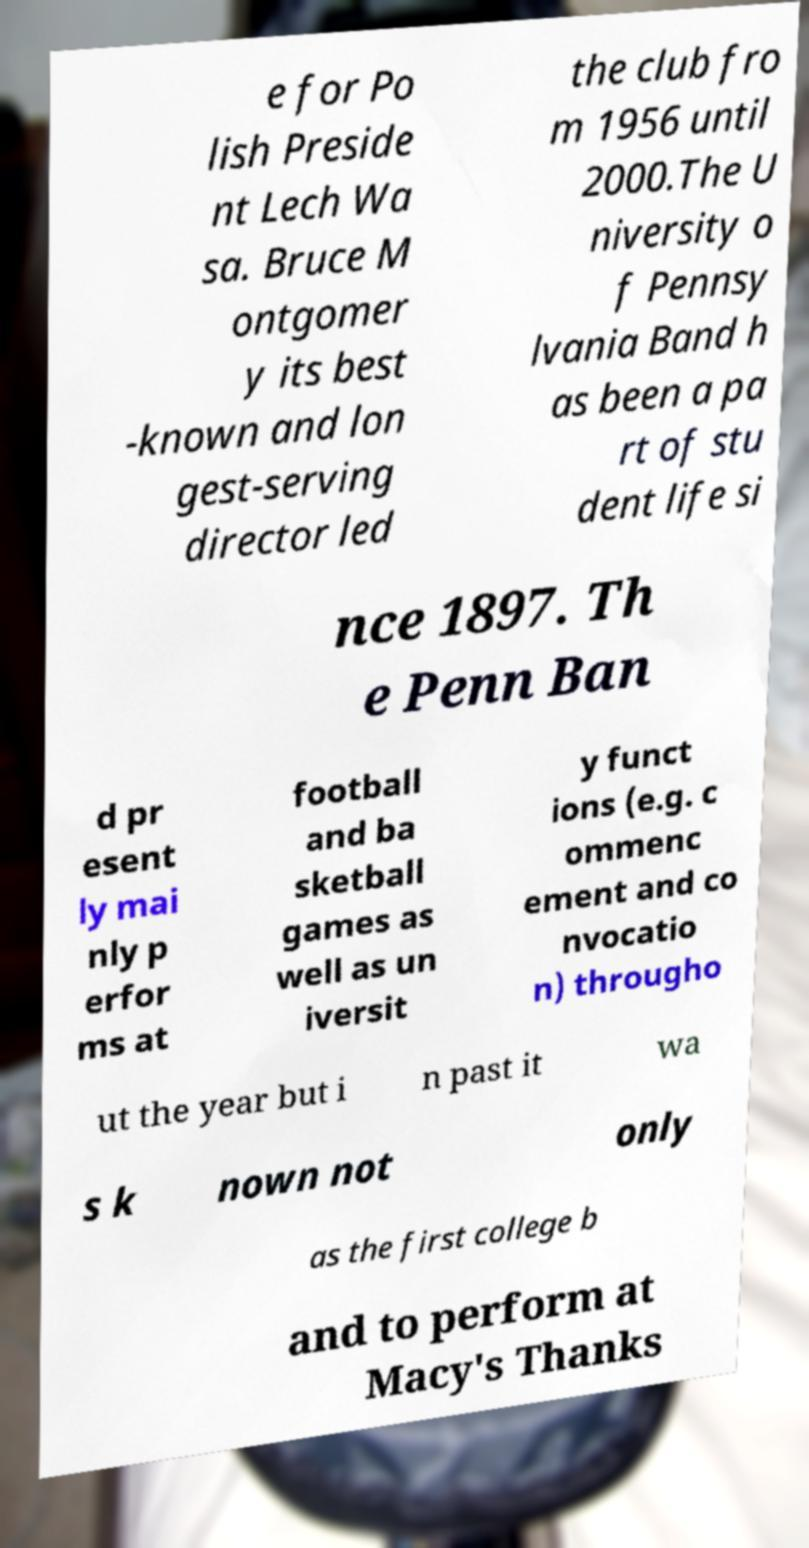I need the written content from this picture converted into text. Can you do that? e for Po lish Preside nt Lech Wa sa. Bruce M ontgomer y its best -known and lon gest-serving director led the club fro m 1956 until 2000.The U niversity o f Pennsy lvania Band h as been a pa rt of stu dent life si nce 1897. Th e Penn Ban d pr esent ly mai nly p erfor ms at football and ba sketball games as well as un iversit y funct ions (e.g. c ommenc ement and co nvocatio n) througho ut the year but i n past it wa s k nown not only as the first college b and to perform at Macy's Thanks 